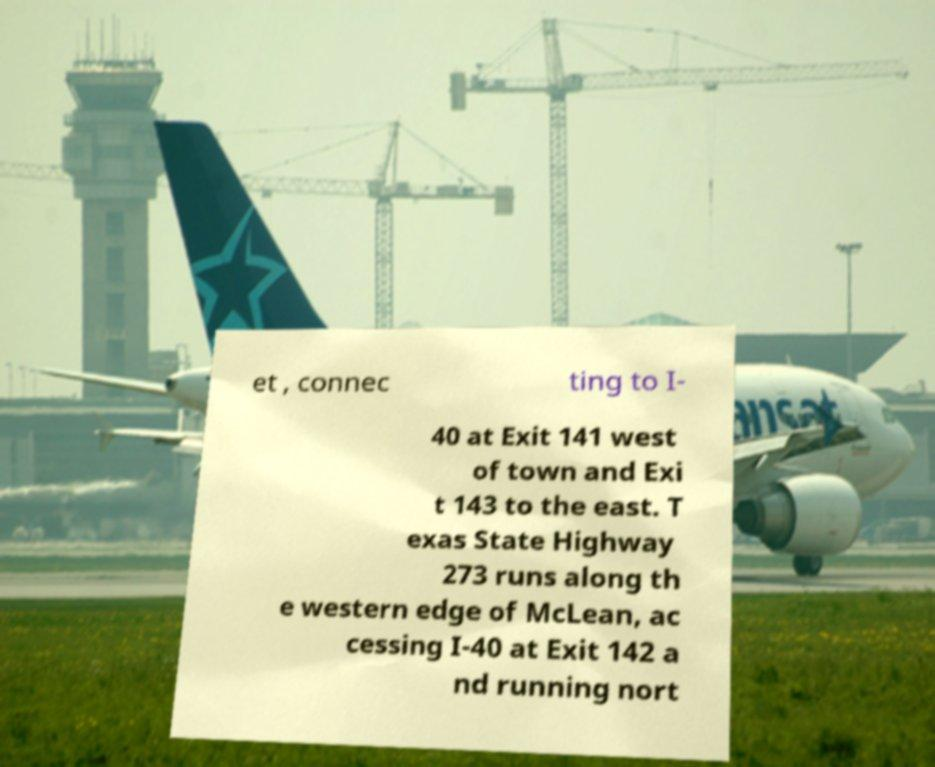Please identify and transcribe the text found in this image. et , connec ting to I- 40 at Exit 141 west of town and Exi t 143 to the east. T exas State Highway 273 runs along th e western edge of McLean, ac cessing I-40 at Exit 142 a nd running nort 